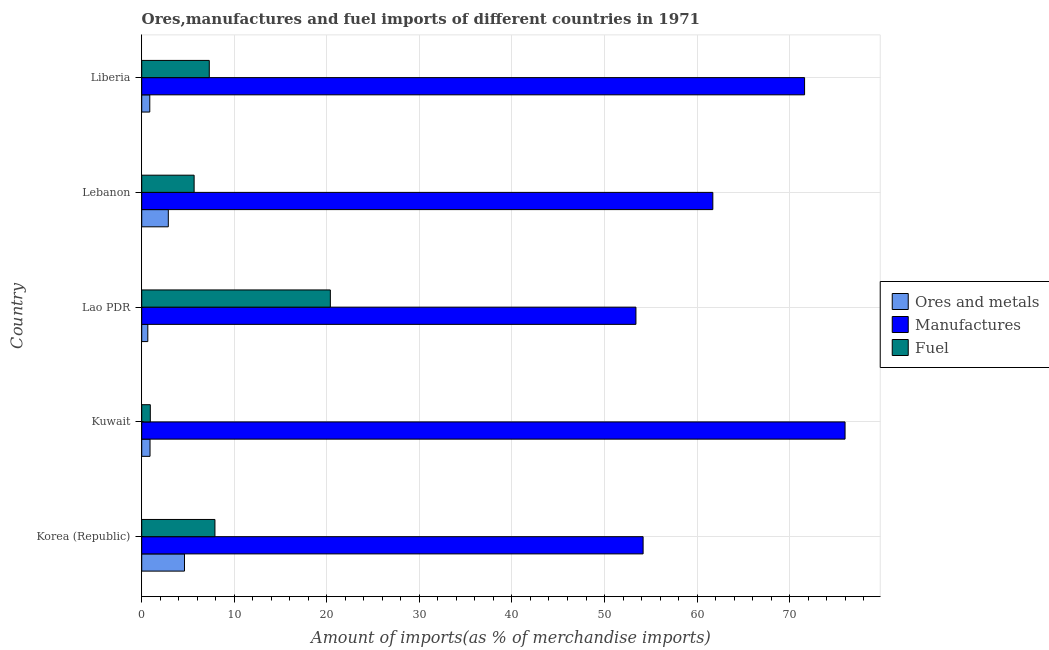How many different coloured bars are there?
Your response must be concise. 3. Are the number of bars per tick equal to the number of legend labels?
Offer a terse response. Yes. In how many cases, is the number of bars for a given country not equal to the number of legend labels?
Ensure brevity in your answer.  0. What is the percentage of ores and metals imports in Lao PDR?
Provide a succinct answer. 0.66. Across all countries, what is the maximum percentage of fuel imports?
Give a very brief answer. 20.38. Across all countries, what is the minimum percentage of fuel imports?
Provide a succinct answer. 0.93. In which country was the percentage of ores and metals imports maximum?
Provide a succinct answer. Korea (Republic). In which country was the percentage of ores and metals imports minimum?
Make the answer very short. Lao PDR. What is the total percentage of fuel imports in the graph?
Keep it short and to the point. 42.18. What is the difference between the percentage of manufactures imports in Lebanon and that in Liberia?
Your answer should be compact. -9.91. What is the difference between the percentage of ores and metals imports in Lao PDR and the percentage of manufactures imports in Liberia?
Provide a succinct answer. -70.96. What is the average percentage of fuel imports per country?
Make the answer very short. 8.44. What is the difference between the percentage of fuel imports and percentage of ores and metals imports in Kuwait?
Offer a very short reply. 0.03. What is the ratio of the percentage of fuel imports in Korea (Republic) to that in Lao PDR?
Offer a terse response. 0.39. What is the difference between the highest and the second highest percentage of fuel imports?
Your answer should be compact. 12.47. What is the difference between the highest and the lowest percentage of ores and metals imports?
Your answer should be compact. 3.96. In how many countries, is the percentage of ores and metals imports greater than the average percentage of ores and metals imports taken over all countries?
Keep it short and to the point. 2. What does the 2nd bar from the top in Liberia represents?
Keep it short and to the point. Manufactures. What does the 2nd bar from the bottom in Lao PDR represents?
Your response must be concise. Manufactures. What is the difference between two consecutive major ticks on the X-axis?
Provide a short and direct response. 10. Are the values on the major ticks of X-axis written in scientific E-notation?
Your answer should be very brief. No. Does the graph contain any zero values?
Provide a short and direct response. No. How are the legend labels stacked?
Provide a succinct answer. Vertical. What is the title of the graph?
Make the answer very short. Ores,manufactures and fuel imports of different countries in 1971. Does "Ores and metals" appear as one of the legend labels in the graph?
Offer a terse response. Yes. What is the label or title of the X-axis?
Keep it short and to the point. Amount of imports(as % of merchandise imports). What is the Amount of imports(as % of merchandise imports) in Ores and metals in Korea (Republic)?
Give a very brief answer. 4.62. What is the Amount of imports(as % of merchandise imports) of Manufactures in Korea (Republic)?
Make the answer very short. 54.17. What is the Amount of imports(as % of merchandise imports) in Fuel in Korea (Republic)?
Ensure brevity in your answer.  7.91. What is the Amount of imports(as % of merchandise imports) of Ores and metals in Kuwait?
Offer a very short reply. 0.9. What is the Amount of imports(as % of merchandise imports) in Manufactures in Kuwait?
Ensure brevity in your answer.  75.99. What is the Amount of imports(as % of merchandise imports) in Fuel in Kuwait?
Provide a succinct answer. 0.93. What is the Amount of imports(as % of merchandise imports) of Ores and metals in Lao PDR?
Make the answer very short. 0.66. What is the Amount of imports(as % of merchandise imports) of Manufactures in Lao PDR?
Give a very brief answer. 53.4. What is the Amount of imports(as % of merchandise imports) in Fuel in Lao PDR?
Ensure brevity in your answer.  20.38. What is the Amount of imports(as % of merchandise imports) in Ores and metals in Lebanon?
Ensure brevity in your answer.  2.87. What is the Amount of imports(as % of merchandise imports) of Manufactures in Lebanon?
Make the answer very short. 61.7. What is the Amount of imports(as % of merchandise imports) in Fuel in Lebanon?
Offer a terse response. 5.66. What is the Amount of imports(as % of merchandise imports) of Ores and metals in Liberia?
Provide a succinct answer. 0.87. What is the Amount of imports(as % of merchandise imports) in Manufactures in Liberia?
Keep it short and to the point. 71.62. What is the Amount of imports(as % of merchandise imports) of Fuel in Liberia?
Give a very brief answer. 7.3. Across all countries, what is the maximum Amount of imports(as % of merchandise imports) in Ores and metals?
Your response must be concise. 4.62. Across all countries, what is the maximum Amount of imports(as % of merchandise imports) in Manufactures?
Keep it short and to the point. 75.99. Across all countries, what is the maximum Amount of imports(as % of merchandise imports) in Fuel?
Make the answer very short. 20.38. Across all countries, what is the minimum Amount of imports(as % of merchandise imports) in Ores and metals?
Keep it short and to the point. 0.66. Across all countries, what is the minimum Amount of imports(as % of merchandise imports) in Manufactures?
Ensure brevity in your answer.  53.4. Across all countries, what is the minimum Amount of imports(as % of merchandise imports) in Fuel?
Offer a very short reply. 0.93. What is the total Amount of imports(as % of merchandise imports) in Ores and metals in the graph?
Provide a succinct answer. 9.92. What is the total Amount of imports(as % of merchandise imports) in Manufactures in the graph?
Your answer should be compact. 316.87. What is the total Amount of imports(as % of merchandise imports) in Fuel in the graph?
Offer a terse response. 42.18. What is the difference between the Amount of imports(as % of merchandise imports) in Ores and metals in Korea (Republic) and that in Kuwait?
Give a very brief answer. 3.72. What is the difference between the Amount of imports(as % of merchandise imports) of Manufactures in Korea (Republic) and that in Kuwait?
Your response must be concise. -21.82. What is the difference between the Amount of imports(as % of merchandise imports) in Fuel in Korea (Republic) and that in Kuwait?
Provide a short and direct response. 6.98. What is the difference between the Amount of imports(as % of merchandise imports) in Ores and metals in Korea (Republic) and that in Lao PDR?
Provide a succinct answer. 3.96. What is the difference between the Amount of imports(as % of merchandise imports) of Manufactures in Korea (Republic) and that in Lao PDR?
Provide a short and direct response. 0.77. What is the difference between the Amount of imports(as % of merchandise imports) in Fuel in Korea (Republic) and that in Lao PDR?
Offer a terse response. -12.47. What is the difference between the Amount of imports(as % of merchandise imports) of Ores and metals in Korea (Republic) and that in Lebanon?
Your answer should be very brief. 1.75. What is the difference between the Amount of imports(as % of merchandise imports) in Manufactures in Korea (Republic) and that in Lebanon?
Your response must be concise. -7.53. What is the difference between the Amount of imports(as % of merchandise imports) of Fuel in Korea (Republic) and that in Lebanon?
Offer a terse response. 2.25. What is the difference between the Amount of imports(as % of merchandise imports) in Ores and metals in Korea (Republic) and that in Liberia?
Your answer should be very brief. 3.75. What is the difference between the Amount of imports(as % of merchandise imports) of Manufactures in Korea (Republic) and that in Liberia?
Provide a short and direct response. -17.45. What is the difference between the Amount of imports(as % of merchandise imports) of Fuel in Korea (Republic) and that in Liberia?
Provide a succinct answer. 0.61. What is the difference between the Amount of imports(as % of merchandise imports) of Ores and metals in Kuwait and that in Lao PDR?
Give a very brief answer. 0.24. What is the difference between the Amount of imports(as % of merchandise imports) in Manufactures in Kuwait and that in Lao PDR?
Provide a short and direct response. 22.59. What is the difference between the Amount of imports(as % of merchandise imports) of Fuel in Kuwait and that in Lao PDR?
Offer a very short reply. -19.45. What is the difference between the Amount of imports(as % of merchandise imports) of Ores and metals in Kuwait and that in Lebanon?
Offer a terse response. -1.98. What is the difference between the Amount of imports(as % of merchandise imports) in Manufactures in Kuwait and that in Lebanon?
Your answer should be very brief. 14.29. What is the difference between the Amount of imports(as % of merchandise imports) of Fuel in Kuwait and that in Lebanon?
Give a very brief answer. -4.73. What is the difference between the Amount of imports(as % of merchandise imports) in Ores and metals in Kuwait and that in Liberia?
Offer a very short reply. 0.03. What is the difference between the Amount of imports(as % of merchandise imports) of Manufactures in Kuwait and that in Liberia?
Make the answer very short. 4.37. What is the difference between the Amount of imports(as % of merchandise imports) in Fuel in Kuwait and that in Liberia?
Your response must be concise. -6.37. What is the difference between the Amount of imports(as % of merchandise imports) of Ores and metals in Lao PDR and that in Lebanon?
Your answer should be very brief. -2.22. What is the difference between the Amount of imports(as % of merchandise imports) of Manufactures in Lao PDR and that in Lebanon?
Your answer should be compact. -8.31. What is the difference between the Amount of imports(as % of merchandise imports) in Fuel in Lao PDR and that in Lebanon?
Ensure brevity in your answer.  14.72. What is the difference between the Amount of imports(as % of merchandise imports) in Ores and metals in Lao PDR and that in Liberia?
Make the answer very short. -0.21. What is the difference between the Amount of imports(as % of merchandise imports) of Manufactures in Lao PDR and that in Liberia?
Keep it short and to the point. -18.22. What is the difference between the Amount of imports(as % of merchandise imports) in Fuel in Lao PDR and that in Liberia?
Provide a short and direct response. 13.08. What is the difference between the Amount of imports(as % of merchandise imports) of Ores and metals in Lebanon and that in Liberia?
Make the answer very short. 2. What is the difference between the Amount of imports(as % of merchandise imports) of Manufactures in Lebanon and that in Liberia?
Your answer should be compact. -9.91. What is the difference between the Amount of imports(as % of merchandise imports) of Fuel in Lebanon and that in Liberia?
Ensure brevity in your answer.  -1.64. What is the difference between the Amount of imports(as % of merchandise imports) in Ores and metals in Korea (Republic) and the Amount of imports(as % of merchandise imports) in Manufactures in Kuwait?
Your response must be concise. -71.37. What is the difference between the Amount of imports(as % of merchandise imports) of Ores and metals in Korea (Republic) and the Amount of imports(as % of merchandise imports) of Fuel in Kuwait?
Ensure brevity in your answer.  3.69. What is the difference between the Amount of imports(as % of merchandise imports) of Manufactures in Korea (Republic) and the Amount of imports(as % of merchandise imports) of Fuel in Kuwait?
Ensure brevity in your answer.  53.24. What is the difference between the Amount of imports(as % of merchandise imports) of Ores and metals in Korea (Republic) and the Amount of imports(as % of merchandise imports) of Manufactures in Lao PDR?
Provide a succinct answer. -48.78. What is the difference between the Amount of imports(as % of merchandise imports) in Ores and metals in Korea (Republic) and the Amount of imports(as % of merchandise imports) in Fuel in Lao PDR?
Offer a very short reply. -15.76. What is the difference between the Amount of imports(as % of merchandise imports) of Manufactures in Korea (Republic) and the Amount of imports(as % of merchandise imports) of Fuel in Lao PDR?
Give a very brief answer. 33.79. What is the difference between the Amount of imports(as % of merchandise imports) in Ores and metals in Korea (Republic) and the Amount of imports(as % of merchandise imports) in Manufactures in Lebanon?
Your answer should be very brief. -57.08. What is the difference between the Amount of imports(as % of merchandise imports) in Ores and metals in Korea (Republic) and the Amount of imports(as % of merchandise imports) in Fuel in Lebanon?
Make the answer very short. -1.04. What is the difference between the Amount of imports(as % of merchandise imports) in Manufactures in Korea (Republic) and the Amount of imports(as % of merchandise imports) in Fuel in Lebanon?
Keep it short and to the point. 48.51. What is the difference between the Amount of imports(as % of merchandise imports) of Ores and metals in Korea (Republic) and the Amount of imports(as % of merchandise imports) of Manufactures in Liberia?
Provide a succinct answer. -67. What is the difference between the Amount of imports(as % of merchandise imports) in Ores and metals in Korea (Republic) and the Amount of imports(as % of merchandise imports) in Fuel in Liberia?
Your answer should be very brief. -2.68. What is the difference between the Amount of imports(as % of merchandise imports) of Manufactures in Korea (Republic) and the Amount of imports(as % of merchandise imports) of Fuel in Liberia?
Your response must be concise. 46.87. What is the difference between the Amount of imports(as % of merchandise imports) in Ores and metals in Kuwait and the Amount of imports(as % of merchandise imports) in Manufactures in Lao PDR?
Provide a short and direct response. -52.5. What is the difference between the Amount of imports(as % of merchandise imports) of Ores and metals in Kuwait and the Amount of imports(as % of merchandise imports) of Fuel in Lao PDR?
Provide a succinct answer. -19.48. What is the difference between the Amount of imports(as % of merchandise imports) of Manufactures in Kuwait and the Amount of imports(as % of merchandise imports) of Fuel in Lao PDR?
Provide a short and direct response. 55.61. What is the difference between the Amount of imports(as % of merchandise imports) of Ores and metals in Kuwait and the Amount of imports(as % of merchandise imports) of Manufactures in Lebanon?
Make the answer very short. -60.8. What is the difference between the Amount of imports(as % of merchandise imports) of Ores and metals in Kuwait and the Amount of imports(as % of merchandise imports) of Fuel in Lebanon?
Give a very brief answer. -4.76. What is the difference between the Amount of imports(as % of merchandise imports) in Manufactures in Kuwait and the Amount of imports(as % of merchandise imports) in Fuel in Lebanon?
Your answer should be very brief. 70.33. What is the difference between the Amount of imports(as % of merchandise imports) in Ores and metals in Kuwait and the Amount of imports(as % of merchandise imports) in Manufactures in Liberia?
Provide a succinct answer. -70.72. What is the difference between the Amount of imports(as % of merchandise imports) in Ores and metals in Kuwait and the Amount of imports(as % of merchandise imports) in Fuel in Liberia?
Keep it short and to the point. -6.4. What is the difference between the Amount of imports(as % of merchandise imports) in Manufactures in Kuwait and the Amount of imports(as % of merchandise imports) in Fuel in Liberia?
Your answer should be compact. 68.69. What is the difference between the Amount of imports(as % of merchandise imports) of Ores and metals in Lao PDR and the Amount of imports(as % of merchandise imports) of Manufactures in Lebanon?
Your response must be concise. -61.04. What is the difference between the Amount of imports(as % of merchandise imports) in Ores and metals in Lao PDR and the Amount of imports(as % of merchandise imports) in Fuel in Lebanon?
Your response must be concise. -5. What is the difference between the Amount of imports(as % of merchandise imports) of Manufactures in Lao PDR and the Amount of imports(as % of merchandise imports) of Fuel in Lebanon?
Provide a succinct answer. 47.73. What is the difference between the Amount of imports(as % of merchandise imports) of Ores and metals in Lao PDR and the Amount of imports(as % of merchandise imports) of Manufactures in Liberia?
Ensure brevity in your answer.  -70.96. What is the difference between the Amount of imports(as % of merchandise imports) of Ores and metals in Lao PDR and the Amount of imports(as % of merchandise imports) of Fuel in Liberia?
Provide a succinct answer. -6.64. What is the difference between the Amount of imports(as % of merchandise imports) in Manufactures in Lao PDR and the Amount of imports(as % of merchandise imports) in Fuel in Liberia?
Your answer should be very brief. 46.1. What is the difference between the Amount of imports(as % of merchandise imports) in Ores and metals in Lebanon and the Amount of imports(as % of merchandise imports) in Manufactures in Liberia?
Offer a very short reply. -68.74. What is the difference between the Amount of imports(as % of merchandise imports) in Ores and metals in Lebanon and the Amount of imports(as % of merchandise imports) in Fuel in Liberia?
Make the answer very short. -4.43. What is the difference between the Amount of imports(as % of merchandise imports) in Manufactures in Lebanon and the Amount of imports(as % of merchandise imports) in Fuel in Liberia?
Give a very brief answer. 54.4. What is the average Amount of imports(as % of merchandise imports) of Ores and metals per country?
Your answer should be very brief. 1.98. What is the average Amount of imports(as % of merchandise imports) of Manufactures per country?
Keep it short and to the point. 63.37. What is the average Amount of imports(as % of merchandise imports) of Fuel per country?
Your answer should be compact. 8.44. What is the difference between the Amount of imports(as % of merchandise imports) in Ores and metals and Amount of imports(as % of merchandise imports) in Manufactures in Korea (Republic)?
Offer a terse response. -49.55. What is the difference between the Amount of imports(as % of merchandise imports) of Ores and metals and Amount of imports(as % of merchandise imports) of Fuel in Korea (Republic)?
Provide a short and direct response. -3.29. What is the difference between the Amount of imports(as % of merchandise imports) in Manufactures and Amount of imports(as % of merchandise imports) in Fuel in Korea (Republic)?
Offer a very short reply. 46.26. What is the difference between the Amount of imports(as % of merchandise imports) of Ores and metals and Amount of imports(as % of merchandise imports) of Manufactures in Kuwait?
Make the answer very short. -75.09. What is the difference between the Amount of imports(as % of merchandise imports) in Ores and metals and Amount of imports(as % of merchandise imports) in Fuel in Kuwait?
Make the answer very short. -0.03. What is the difference between the Amount of imports(as % of merchandise imports) in Manufactures and Amount of imports(as % of merchandise imports) in Fuel in Kuwait?
Offer a terse response. 75.06. What is the difference between the Amount of imports(as % of merchandise imports) in Ores and metals and Amount of imports(as % of merchandise imports) in Manufactures in Lao PDR?
Your answer should be compact. -52.74. What is the difference between the Amount of imports(as % of merchandise imports) in Ores and metals and Amount of imports(as % of merchandise imports) in Fuel in Lao PDR?
Give a very brief answer. -19.72. What is the difference between the Amount of imports(as % of merchandise imports) in Manufactures and Amount of imports(as % of merchandise imports) in Fuel in Lao PDR?
Offer a terse response. 33.02. What is the difference between the Amount of imports(as % of merchandise imports) in Ores and metals and Amount of imports(as % of merchandise imports) in Manufactures in Lebanon?
Your answer should be compact. -58.83. What is the difference between the Amount of imports(as % of merchandise imports) in Ores and metals and Amount of imports(as % of merchandise imports) in Fuel in Lebanon?
Ensure brevity in your answer.  -2.79. What is the difference between the Amount of imports(as % of merchandise imports) of Manufactures and Amount of imports(as % of merchandise imports) of Fuel in Lebanon?
Offer a very short reply. 56.04. What is the difference between the Amount of imports(as % of merchandise imports) in Ores and metals and Amount of imports(as % of merchandise imports) in Manufactures in Liberia?
Offer a very short reply. -70.74. What is the difference between the Amount of imports(as % of merchandise imports) of Ores and metals and Amount of imports(as % of merchandise imports) of Fuel in Liberia?
Make the answer very short. -6.43. What is the difference between the Amount of imports(as % of merchandise imports) in Manufactures and Amount of imports(as % of merchandise imports) in Fuel in Liberia?
Your answer should be very brief. 64.32. What is the ratio of the Amount of imports(as % of merchandise imports) of Ores and metals in Korea (Republic) to that in Kuwait?
Provide a short and direct response. 5.14. What is the ratio of the Amount of imports(as % of merchandise imports) of Manufactures in Korea (Republic) to that in Kuwait?
Your response must be concise. 0.71. What is the ratio of the Amount of imports(as % of merchandise imports) of Fuel in Korea (Republic) to that in Kuwait?
Offer a terse response. 8.53. What is the ratio of the Amount of imports(as % of merchandise imports) of Ores and metals in Korea (Republic) to that in Lao PDR?
Offer a terse response. 7.02. What is the ratio of the Amount of imports(as % of merchandise imports) in Manufactures in Korea (Republic) to that in Lao PDR?
Give a very brief answer. 1.01. What is the ratio of the Amount of imports(as % of merchandise imports) of Fuel in Korea (Republic) to that in Lao PDR?
Ensure brevity in your answer.  0.39. What is the ratio of the Amount of imports(as % of merchandise imports) of Ores and metals in Korea (Republic) to that in Lebanon?
Your answer should be compact. 1.61. What is the ratio of the Amount of imports(as % of merchandise imports) of Manufactures in Korea (Republic) to that in Lebanon?
Offer a very short reply. 0.88. What is the ratio of the Amount of imports(as % of merchandise imports) in Fuel in Korea (Republic) to that in Lebanon?
Keep it short and to the point. 1.4. What is the ratio of the Amount of imports(as % of merchandise imports) of Ores and metals in Korea (Republic) to that in Liberia?
Keep it short and to the point. 5.31. What is the ratio of the Amount of imports(as % of merchandise imports) of Manufactures in Korea (Republic) to that in Liberia?
Make the answer very short. 0.76. What is the ratio of the Amount of imports(as % of merchandise imports) in Fuel in Korea (Republic) to that in Liberia?
Your response must be concise. 1.08. What is the ratio of the Amount of imports(as % of merchandise imports) in Ores and metals in Kuwait to that in Lao PDR?
Offer a very short reply. 1.37. What is the ratio of the Amount of imports(as % of merchandise imports) in Manufactures in Kuwait to that in Lao PDR?
Your answer should be very brief. 1.42. What is the ratio of the Amount of imports(as % of merchandise imports) of Fuel in Kuwait to that in Lao PDR?
Make the answer very short. 0.05. What is the ratio of the Amount of imports(as % of merchandise imports) of Ores and metals in Kuwait to that in Lebanon?
Offer a terse response. 0.31. What is the ratio of the Amount of imports(as % of merchandise imports) of Manufactures in Kuwait to that in Lebanon?
Your answer should be compact. 1.23. What is the ratio of the Amount of imports(as % of merchandise imports) in Fuel in Kuwait to that in Lebanon?
Provide a short and direct response. 0.16. What is the ratio of the Amount of imports(as % of merchandise imports) in Ores and metals in Kuwait to that in Liberia?
Provide a short and direct response. 1.03. What is the ratio of the Amount of imports(as % of merchandise imports) in Manufactures in Kuwait to that in Liberia?
Give a very brief answer. 1.06. What is the ratio of the Amount of imports(as % of merchandise imports) of Fuel in Kuwait to that in Liberia?
Offer a terse response. 0.13. What is the ratio of the Amount of imports(as % of merchandise imports) of Ores and metals in Lao PDR to that in Lebanon?
Your response must be concise. 0.23. What is the ratio of the Amount of imports(as % of merchandise imports) of Manufactures in Lao PDR to that in Lebanon?
Offer a terse response. 0.87. What is the ratio of the Amount of imports(as % of merchandise imports) in Fuel in Lao PDR to that in Lebanon?
Give a very brief answer. 3.6. What is the ratio of the Amount of imports(as % of merchandise imports) of Ores and metals in Lao PDR to that in Liberia?
Ensure brevity in your answer.  0.76. What is the ratio of the Amount of imports(as % of merchandise imports) of Manufactures in Lao PDR to that in Liberia?
Make the answer very short. 0.75. What is the ratio of the Amount of imports(as % of merchandise imports) of Fuel in Lao PDR to that in Liberia?
Ensure brevity in your answer.  2.79. What is the ratio of the Amount of imports(as % of merchandise imports) of Ores and metals in Lebanon to that in Liberia?
Offer a very short reply. 3.3. What is the ratio of the Amount of imports(as % of merchandise imports) in Manufactures in Lebanon to that in Liberia?
Your response must be concise. 0.86. What is the ratio of the Amount of imports(as % of merchandise imports) of Fuel in Lebanon to that in Liberia?
Offer a terse response. 0.78. What is the difference between the highest and the second highest Amount of imports(as % of merchandise imports) in Ores and metals?
Your answer should be compact. 1.75. What is the difference between the highest and the second highest Amount of imports(as % of merchandise imports) of Manufactures?
Give a very brief answer. 4.37. What is the difference between the highest and the second highest Amount of imports(as % of merchandise imports) of Fuel?
Your answer should be very brief. 12.47. What is the difference between the highest and the lowest Amount of imports(as % of merchandise imports) in Ores and metals?
Ensure brevity in your answer.  3.96. What is the difference between the highest and the lowest Amount of imports(as % of merchandise imports) in Manufactures?
Provide a succinct answer. 22.59. What is the difference between the highest and the lowest Amount of imports(as % of merchandise imports) of Fuel?
Provide a succinct answer. 19.45. 